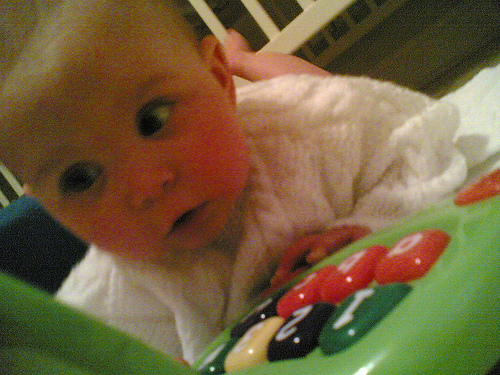<image>
Can you confirm if the baby is on the floor? Yes. Looking at the image, I can see the baby is positioned on top of the floor, with the floor providing support. Is the baby on the toy? Yes. Looking at the image, I can see the baby is positioned on top of the toy, with the toy providing support. 